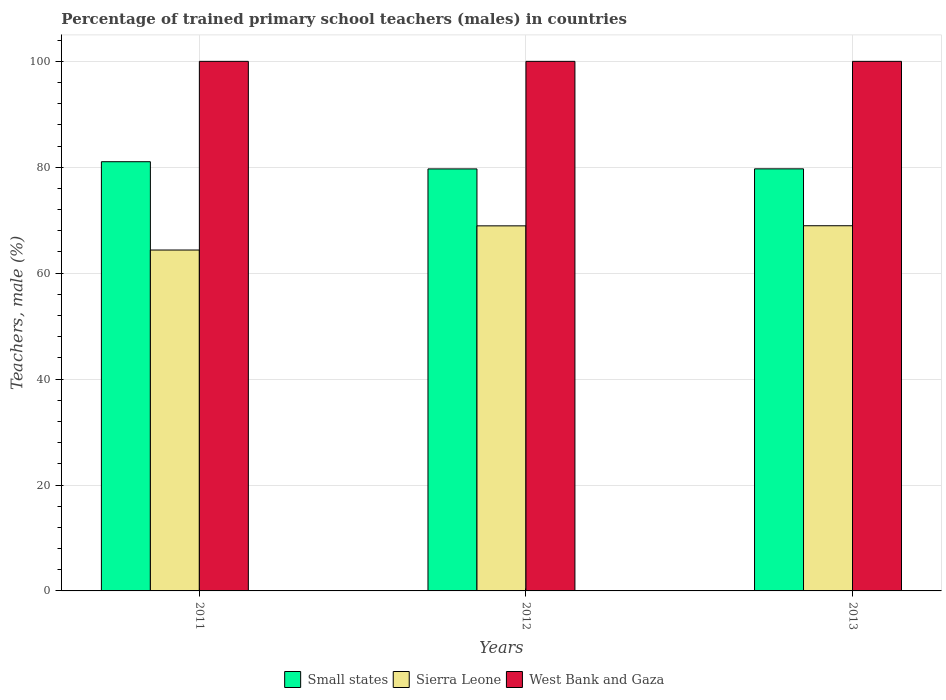How many different coloured bars are there?
Make the answer very short. 3. How many groups of bars are there?
Provide a short and direct response. 3. Are the number of bars per tick equal to the number of legend labels?
Your response must be concise. Yes. Are the number of bars on each tick of the X-axis equal?
Your answer should be very brief. Yes. How many bars are there on the 1st tick from the left?
Ensure brevity in your answer.  3. How many bars are there on the 3rd tick from the right?
Offer a very short reply. 3. What is the label of the 3rd group of bars from the left?
Provide a short and direct response. 2013. Across all years, what is the maximum percentage of trained primary school teachers (males) in Sierra Leone?
Provide a succinct answer. 68.96. Across all years, what is the minimum percentage of trained primary school teachers (males) in Small states?
Provide a succinct answer. 79.69. In which year was the percentage of trained primary school teachers (males) in West Bank and Gaza maximum?
Provide a short and direct response. 2011. What is the total percentage of trained primary school teachers (males) in Sierra Leone in the graph?
Keep it short and to the point. 202.27. What is the difference between the percentage of trained primary school teachers (males) in West Bank and Gaza in 2012 and the percentage of trained primary school teachers (males) in Small states in 2013?
Ensure brevity in your answer.  20.3. What is the average percentage of trained primary school teachers (males) in Small states per year?
Keep it short and to the point. 80.15. In the year 2013, what is the difference between the percentage of trained primary school teachers (males) in Sierra Leone and percentage of trained primary school teachers (males) in West Bank and Gaza?
Your response must be concise. -31.04. What is the ratio of the percentage of trained primary school teachers (males) in West Bank and Gaza in 2011 to that in 2012?
Make the answer very short. 1. What is the difference between the highest and the second highest percentage of trained primary school teachers (males) in West Bank and Gaza?
Keep it short and to the point. 0. What is the difference between the highest and the lowest percentage of trained primary school teachers (males) in Sierra Leone?
Give a very brief answer. 4.58. In how many years, is the percentage of trained primary school teachers (males) in Sierra Leone greater than the average percentage of trained primary school teachers (males) in Sierra Leone taken over all years?
Your response must be concise. 2. What does the 2nd bar from the left in 2011 represents?
Your answer should be very brief. Sierra Leone. What does the 2nd bar from the right in 2011 represents?
Your answer should be very brief. Sierra Leone. Are all the bars in the graph horizontal?
Provide a succinct answer. No. What is the difference between two consecutive major ticks on the Y-axis?
Give a very brief answer. 20. Does the graph contain grids?
Give a very brief answer. Yes. How many legend labels are there?
Provide a short and direct response. 3. How are the legend labels stacked?
Ensure brevity in your answer.  Horizontal. What is the title of the graph?
Give a very brief answer. Percentage of trained primary school teachers (males) in countries. Does "Cambodia" appear as one of the legend labels in the graph?
Your answer should be very brief. No. What is the label or title of the X-axis?
Ensure brevity in your answer.  Years. What is the label or title of the Y-axis?
Your answer should be compact. Teachers, male (%). What is the Teachers, male (%) in Small states in 2011?
Offer a terse response. 81.05. What is the Teachers, male (%) in Sierra Leone in 2011?
Offer a terse response. 64.37. What is the Teachers, male (%) of Small states in 2012?
Give a very brief answer. 79.69. What is the Teachers, male (%) in Sierra Leone in 2012?
Provide a short and direct response. 68.94. What is the Teachers, male (%) in Small states in 2013?
Offer a very short reply. 79.7. What is the Teachers, male (%) in Sierra Leone in 2013?
Give a very brief answer. 68.96. Across all years, what is the maximum Teachers, male (%) of Small states?
Offer a very short reply. 81.05. Across all years, what is the maximum Teachers, male (%) in Sierra Leone?
Offer a terse response. 68.96. Across all years, what is the maximum Teachers, male (%) of West Bank and Gaza?
Offer a very short reply. 100. Across all years, what is the minimum Teachers, male (%) in Small states?
Your answer should be very brief. 79.69. Across all years, what is the minimum Teachers, male (%) in Sierra Leone?
Make the answer very short. 64.37. What is the total Teachers, male (%) in Small states in the graph?
Keep it short and to the point. 240.44. What is the total Teachers, male (%) in Sierra Leone in the graph?
Your answer should be very brief. 202.27. What is the total Teachers, male (%) in West Bank and Gaza in the graph?
Your answer should be very brief. 300. What is the difference between the Teachers, male (%) in Small states in 2011 and that in 2012?
Your answer should be compact. 1.36. What is the difference between the Teachers, male (%) in Sierra Leone in 2011 and that in 2012?
Provide a short and direct response. -4.56. What is the difference between the Teachers, male (%) of Small states in 2011 and that in 2013?
Your answer should be compact. 1.35. What is the difference between the Teachers, male (%) in Sierra Leone in 2011 and that in 2013?
Ensure brevity in your answer.  -4.58. What is the difference between the Teachers, male (%) in West Bank and Gaza in 2011 and that in 2013?
Give a very brief answer. 0. What is the difference between the Teachers, male (%) of Small states in 2012 and that in 2013?
Ensure brevity in your answer.  -0.01. What is the difference between the Teachers, male (%) of Sierra Leone in 2012 and that in 2013?
Your answer should be very brief. -0.02. What is the difference between the Teachers, male (%) of West Bank and Gaza in 2012 and that in 2013?
Provide a succinct answer. 0. What is the difference between the Teachers, male (%) of Small states in 2011 and the Teachers, male (%) of Sierra Leone in 2012?
Provide a succinct answer. 12.11. What is the difference between the Teachers, male (%) in Small states in 2011 and the Teachers, male (%) in West Bank and Gaza in 2012?
Keep it short and to the point. -18.95. What is the difference between the Teachers, male (%) of Sierra Leone in 2011 and the Teachers, male (%) of West Bank and Gaza in 2012?
Ensure brevity in your answer.  -35.63. What is the difference between the Teachers, male (%) in Small states in 2011 and the Teachers, male (%) in Sierra Leone in 2013?
Provide a short and direct response. 12.09. What is the difference between the Teachers, male (%) of Small states in 2011 and the Teachers, male (%) of West Bank and Gaza in 2013?
Your answer should be very brief. -18.95. What is the difference between the Teachers, male (%) of Sierra Leone in 2011 and the Teachers, male (%) of West Bank and Gaza in 2013?
Make the answer very short. -35.63. What is the difference between the Teachers, male (%) of Small states in 2012 and the Teachers, male (%) of Sierra Leone in 2013?
Your response must be concise. 10.73. What is the difference between the Teachers, male (%) of Small states in 2012 and the Teachers, male (%) of West Bank and Gaza in 2013?
Your response must be concise. -20.31. What is the difference between the Teachers, male (%) in Sierra Leone in 2012 and the Teachers, male (%) in West Bank and Gaza in 2013?
Offer a very short reply. -31.06. What is the average Teachers, male (%) in Small states per year?
Keep it short and to the point. 80.15. What is the average Teachers, male (%) of Sierra Leone per year?
Offer a terse response. 67.42. In the year 2011, what is the difference between the Teachers, male (%) of Small states and Teachers, male (%) of Sierra Leone?
Offer a terse response. 16.68. In the year 2011, what is the difference between the Teachers, male (%) in Small states and Teachers, male (%) in West Bank and Gaza?
Provide a short and direct response. -18.95. In the year 2011, what is the difference between the Teachers, male (%) of Sierra Leone and Teachers, male (%) of West Bank and Gaza?
Provide a short and direct response. -35.63. In the year 2012, what is the difference between the Teachers, male (%) in Small states and Teachers, male (%) in Sierra Leone?
Offer a very short reply. 10.75. In the year 2012, what is the difference between the Teachers, male (%) of Small states and Teachers, male (%) of West Bank and Gaza?
Offer a very short reply. -20.31. In the year 2012, what is the difference between the Teachers, male (%) of Sierra Leone and Teachers, male (%) of West Bank and Gaza?
Ensure brevity in your answer.  -31.06. In the year 2013, what is the difference between the Teachers, male (%) of Small states and Teachers, male (%) of Sierra Leone?
Offer a very short reply. 10.74. In the year 2013, what is the difference between the Teachers, male (%) in Small states and Teachers, male (%) in West Bank and Gaza?
Your answer should be very brief. -20.3. In the year 2013, what is the difference between the Teachers, male (%) of Sierra Leone and Teachers, male (%) of West Bank and Gaza?
Provide a short and direct response. -31.04. What is the ratio of the Teachers, male (%) in Small states in 2011 to that in 2012?
Ensure brevity in your answer.  1.02. What is the ratio of the Teachers, male (%) of Sierra Leone in 2011 to that in 2012?
Ensure brevity in your answer.  0.93. What is the ratio of the Teachers, male (%) in Small states in 2011 to that in 2013?
Make the answer very short. 1.02. What is the ratio of the Teachers, male (%) of Sierra Leone in 2011 to that in 2013?
Provide a succinct answer. 0.93. What is the ratio of the Teachers, male (%) of Small states in 2012 to that in 2013?
Offer a terse response. 1. What is the difference between the highest and the second highest Teachers, male (%) in Small states?
Your response must be concise. 1.35. What is the difference between the highest and the second highest Teachers, male (%) in Sierra Leone?
Your answer should be compact. 0.02. What is the difference between the highest and the lowest Teachers, male (%) of Small states?
Your answer should be very brief. 1.36. What is the difference between the highest and the lowest Teachers, male (%) in Sierra Leone?
Provide a succinct answer. 4.58. What is the difference between the highest and the lowest Teachers, male (%) in West Bank and Gaza?
Provide a succinct answer. 0. 